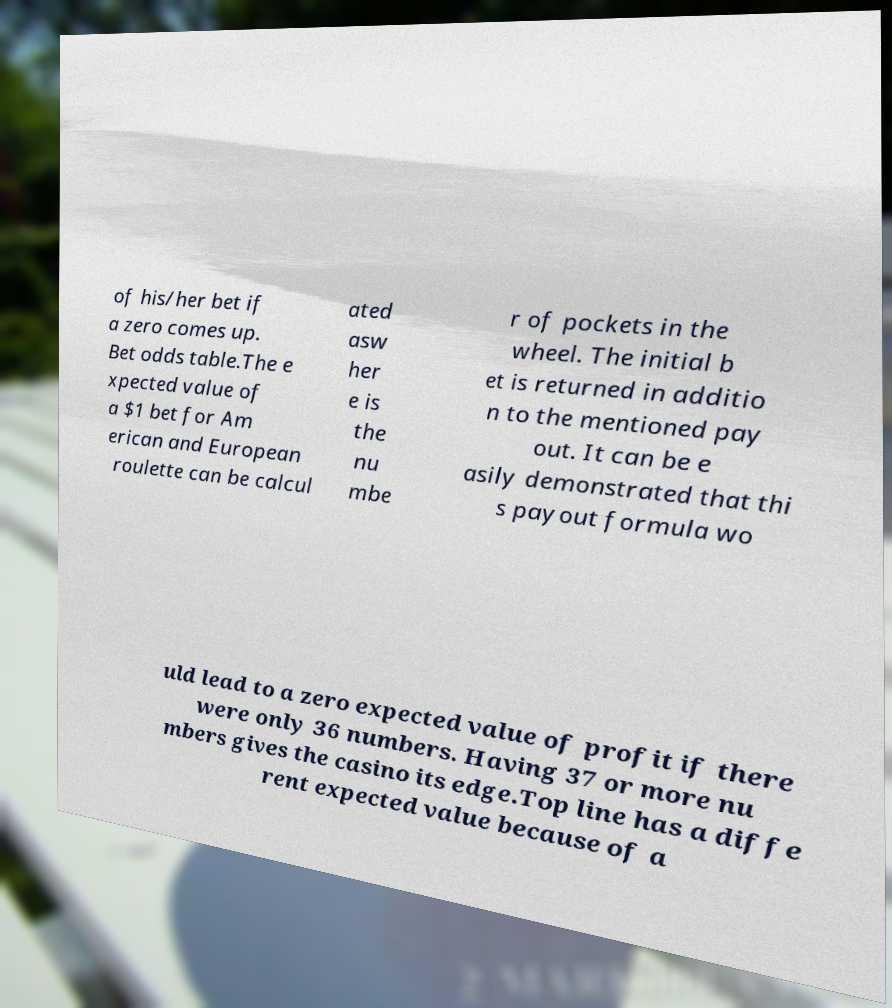Can you read and provide the text displayed in the image?This photo seems to have some interesting text. Can you extract and type it out for me? of his/her bet if a zero comes up. Bet odds table.The e xpected value of a $1 bet for Am erican and European roulette can be calcul ated asw her e is the nu mbe r of pockets in the wheel. The initial b et is returned in additio n to the mentioned pay out. It can be e asily demonstrated that thi s payout formula wo uld lead to a zero expected value of profit if there were only 36 numbers. Having 37 or more nu mbers gives the casino its edge.Top line has a diffe rent expected value because of a 